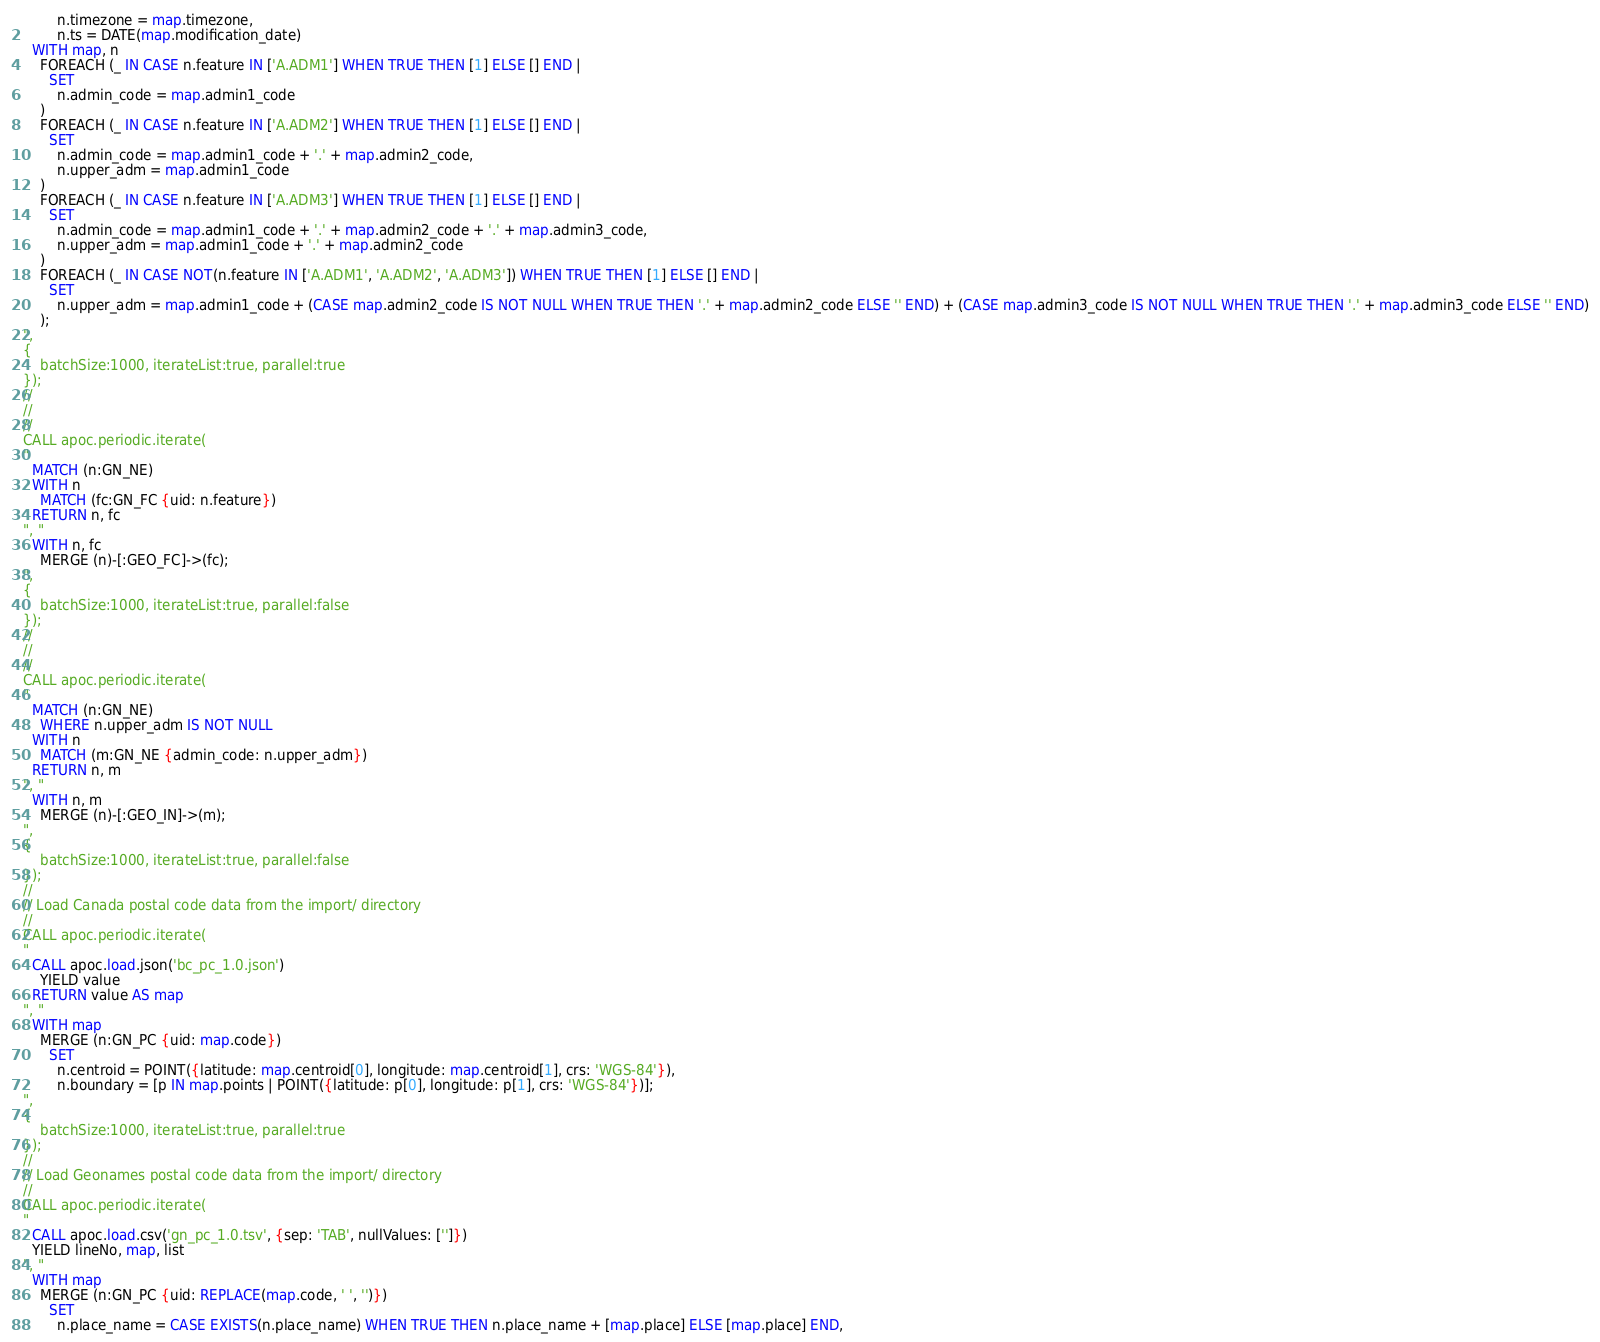Convert code to text. <code><loc_0><loc_0><loc_500><loc_500><_SQL_>        n.timezone = map.timezone,
        n.ts = DATE(map.modification_date)
  WITH map, n
    FOREACH (_ IN CASE n.feature IN ['A.ADM1'] WHEN TRUE THEN [1] ELSE [] END |
      SET
        n.admin_code = map.admin1_code
    )
    FOREACH (_ IN CASE n.feature IN ['A.ADM2'] WHEN TRUE THEN [1] ELSE [] END |
      SET
        n.admin_code = map.admin1_code + '.' + map.admin2_code,
        n.upper_adm = map.admin1_code
    )
    FOREACH (_ IN CASE n.feature IN ['A.ADM3'] WHEN TRUE THEN [1] ELSE [] END |
      SET
        n.admin_code = map.admin1_code + '.' + map.admin2_code + '.' + map.admin3_code,
        n.upper_adm = map.admin1_code + '.' + map.admin2_code
    )
    FOREACH (_ IN CASE NOT(n.feature IN ['A.ADM1', 'A.ADM2', 'A.ADM3']) WHEN TRUE THEN [1] ELSE [] END |
      SET
        n.upper_adm = map.admin1_code + (CASE map.admin2_code IS NOT NULL WHEN TRUE THEN '.' + map.admin2_code ELSE '' END) + (CASE map.admin3_code IS NOT NULL WHEN TRUE THEN '.' + map.admin3_code ELSE '' END)
    );
",
{
    batchSize:1000, iterateList:true, parallel:true
});
//
//
//
CALL apoc.periodic.iterate(
"
  MATCH (n:GN_NE)
  WITH n
    MATCH (fc:GN_FC {uid: n.feature})
  RETURN n, fc
", "
  WITH n, fc
    MERGE (n)-[:GEO_FC]->(fc);
",
{
    batchSize:1000, iterateList:true, parallel:false
});
//
//
//
CALL apoc.periodic.iterate(
"
  MATCH (n:GN_NE)
    WHERE n.upper_adm IS NOT NULL
  WITH n
    MATCH (m:GN_NE {admin_code: n.upper_adm})
  RETURN n, m
", "
  WITH n, m
    MERGE (n)-[:GEO_IN]->(m);
",
{
    batchSize:1000, iterateList:true, parallel:false
});
//
// Load Canada postal code data from the import/ directory
//
CALL apoc.periodic.iterate(
"
  CALL apoc.load.json('bc_pc_1.0.json')
    YIELD value
  RETURN value AS map
", "
  WITH map
    MERGE (n:GN_PC {uid: map.code})
      SET
        n.centroid = POINT({latitude: map.centroid[0], longitude: map.centroid[1], crs: 'WGS-84'}),
        n.boundary = [p IN map.points | POINT({latitude: p[0], longitude: p[1], crs: 'WGS-84'})];
",
{
    batchSize:1000, iterateList:true, parallel:true
});
//
// Load Geonames postal code data from the import/ directory
//
CALL apoc.periodic.iterate(
"
  CALL apoc.load.csv('gn_pc_1.0.tsv', {sep: 'TAB', nullValues: ['']})
  YIELD lineNo, map, list
", "
  WITH map
    MERGE (n:GN_PC {uid: REPLACE(map.code, ' ', '')})
      SET
        n.place_name = CASE EXISTS(n.place_name) WHEN TRUE THEN n.place_name + [map.place] ELSE [map.place] END,</code> 